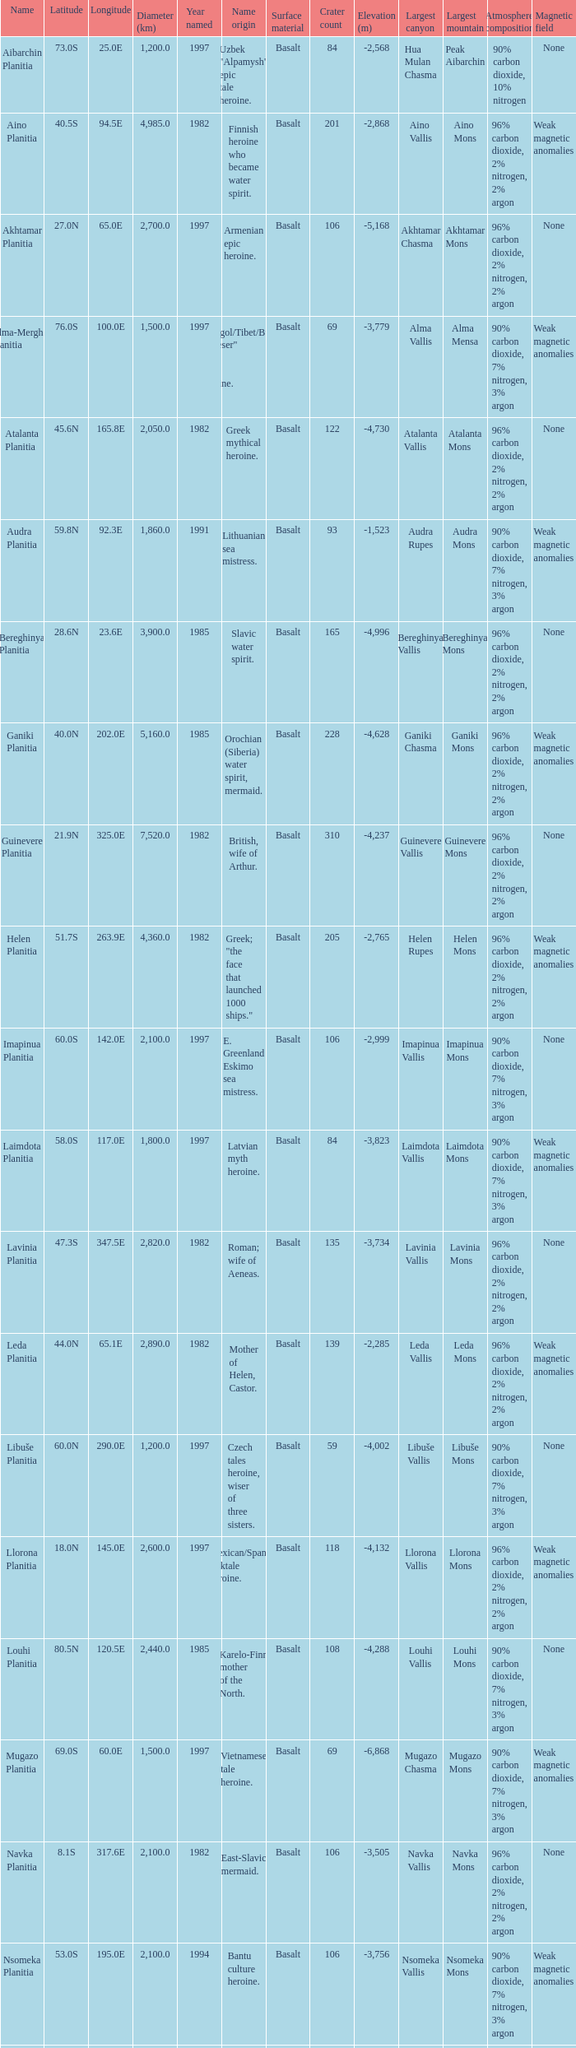0s? 3000.0. 